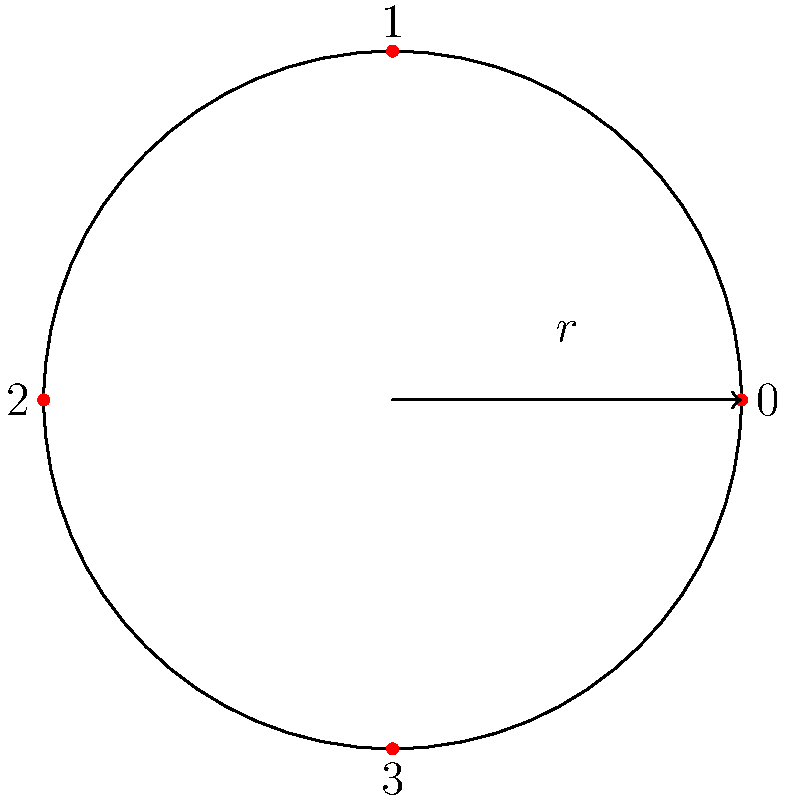In figure skating, a quad jump involves four rotations in the air. If we represent each 90-degree rotation as an element of a cyclic group, what is the order of this group, and which element represents a full 360-degree rotation? To answer this question, we need to understand the cyclic group structure of rotations:

1. The diagram shows a circle divided into four equal parts, representing 90-degree rotations.

2. Each rotation can be thought of as an element of a cyclic group:
   - 0: No rotation (identity element)
   - 1: 90-degree rotation
   - 2: 180-degree rotation
   - 3: 270-degree rotation

3. The order of a cyclic group is the number of elements in the group. In this case, there are 4 distinct rotations, so the order of the group is 4.

4. To find which element represents a full 360-degree rotation, we need to determine which rotation brings us back to the starting position:
   - 1 rotation (90 degrees) is not enough
   - 2 rotations (180 degrees) is not enough
   - 3 rotations (270 degrees) is not enough
   - 4 rotations (360 degrees) brings us back to the starting position

5. In the cyclic group notation, 4 rotations of 90 degrees each is equivalent to the identity element 0, as $4 \equiv 0 \pmod{4}$.

Therefore, the order of the group is 4, and the element representing a full 360-degree rotation is 0 (the identity element).
Answer: Order: 4, Full rotation: 0 